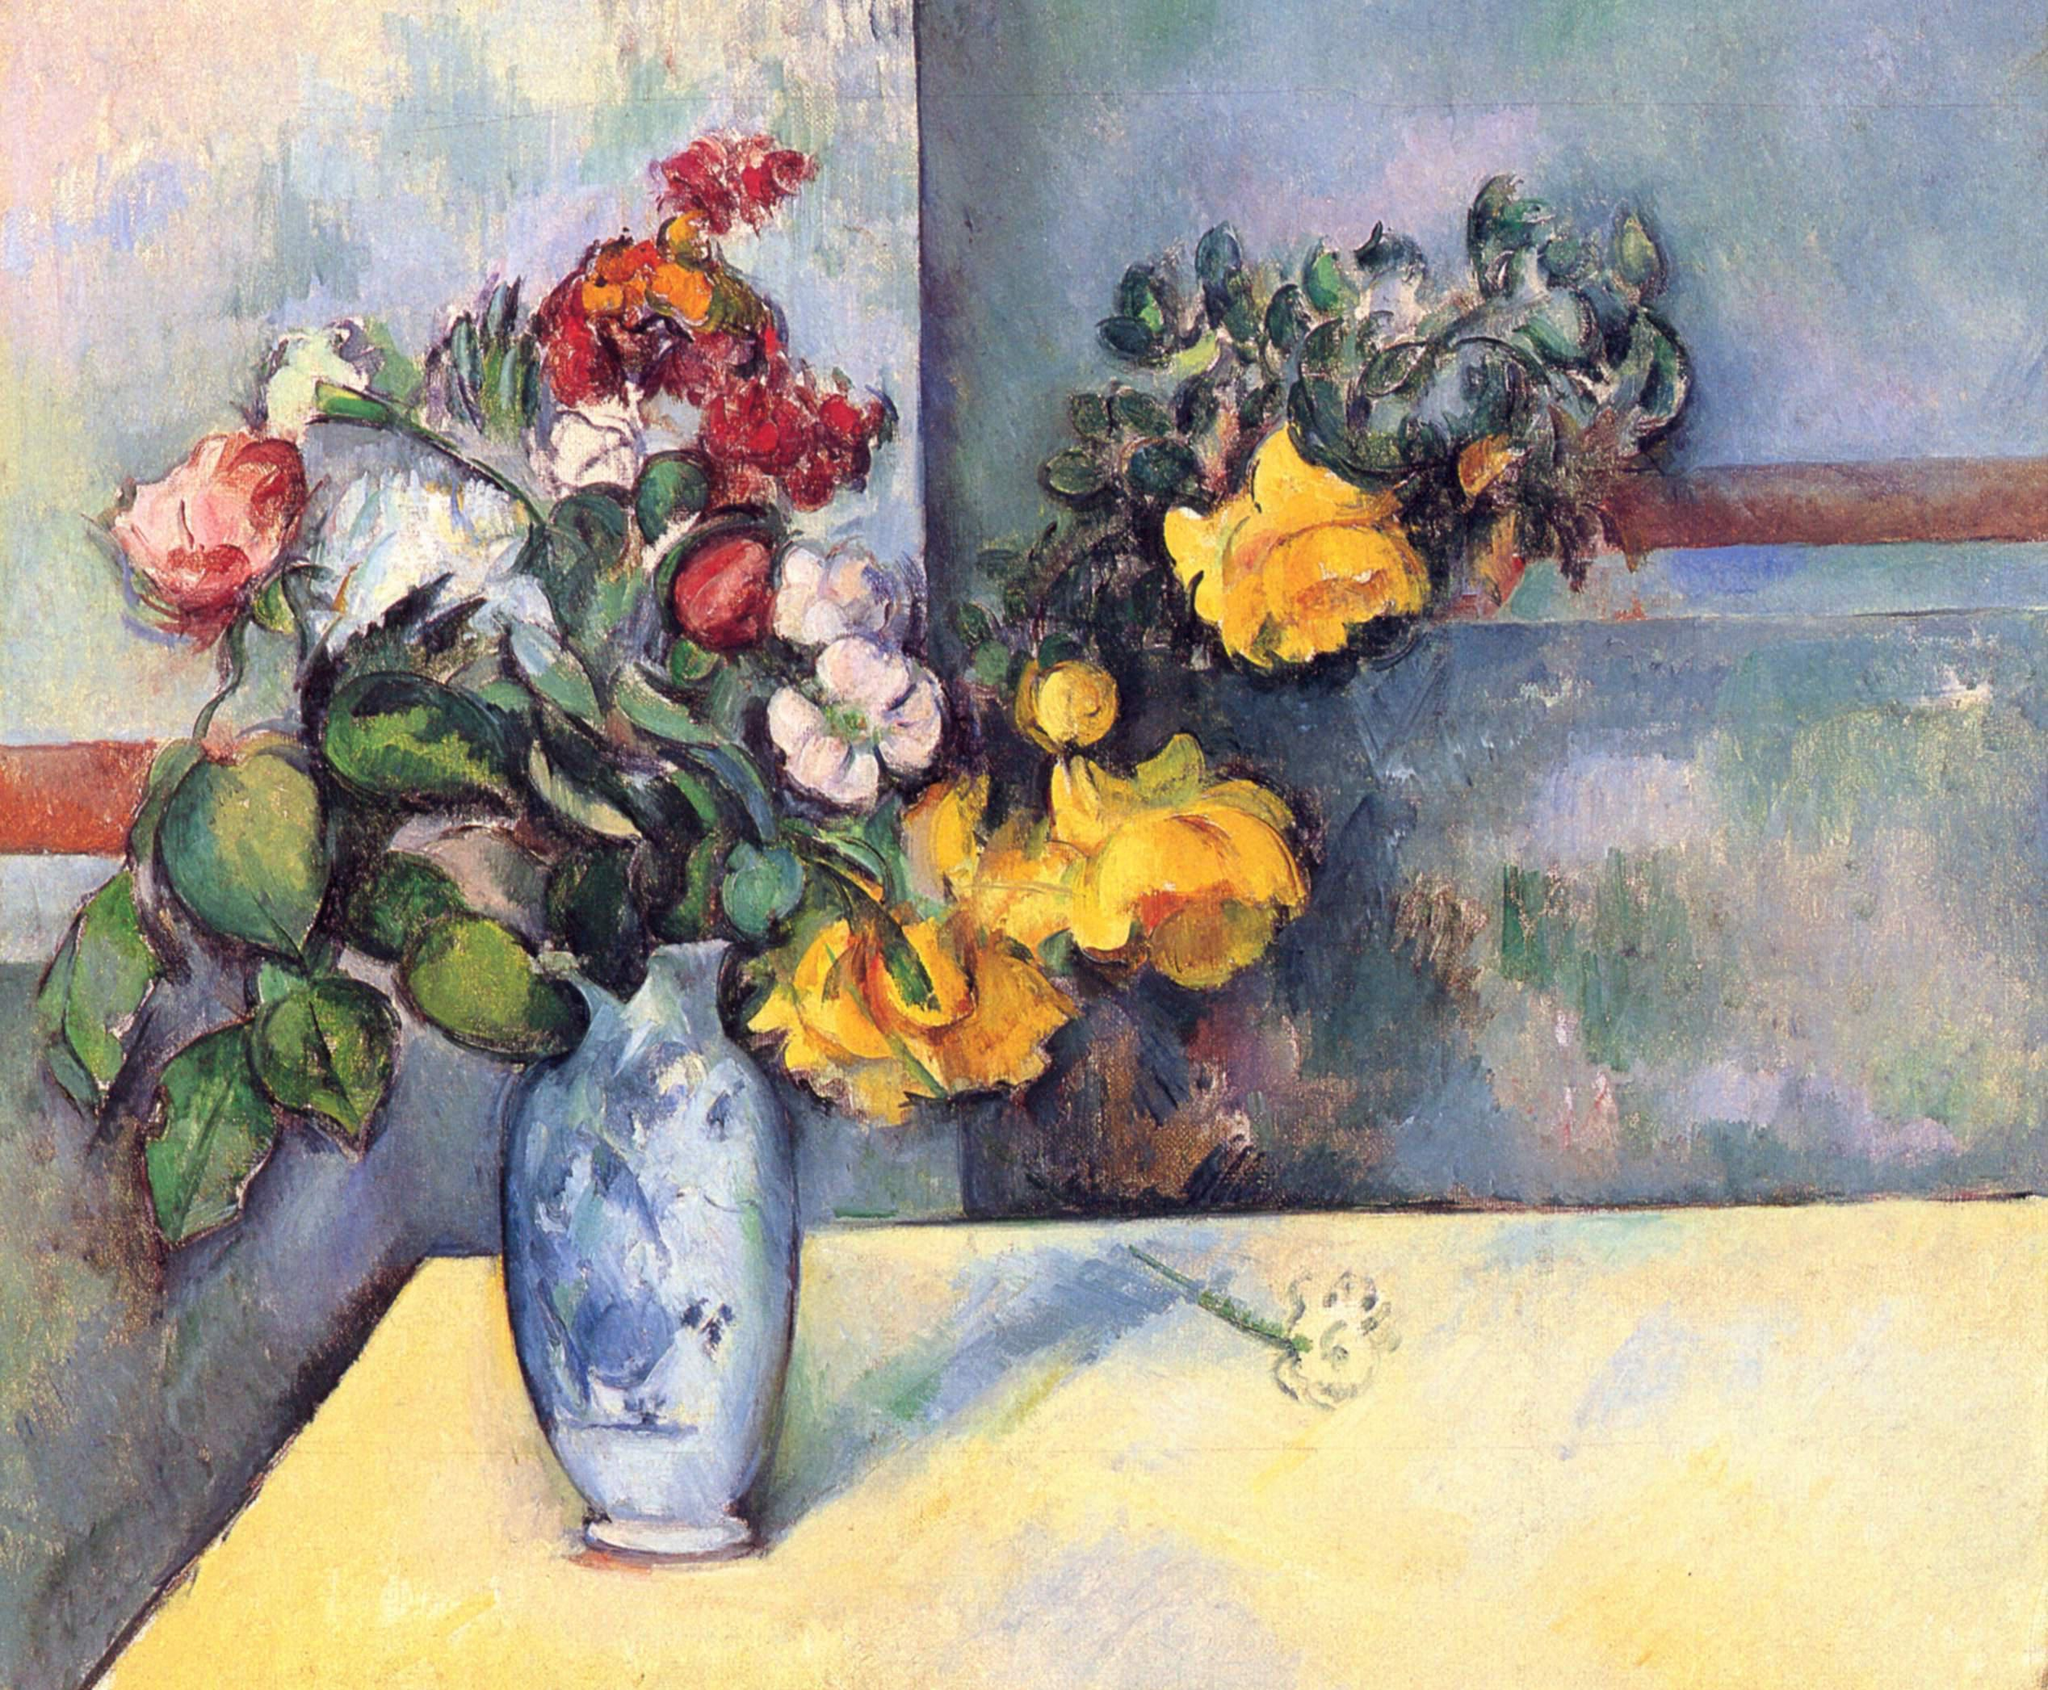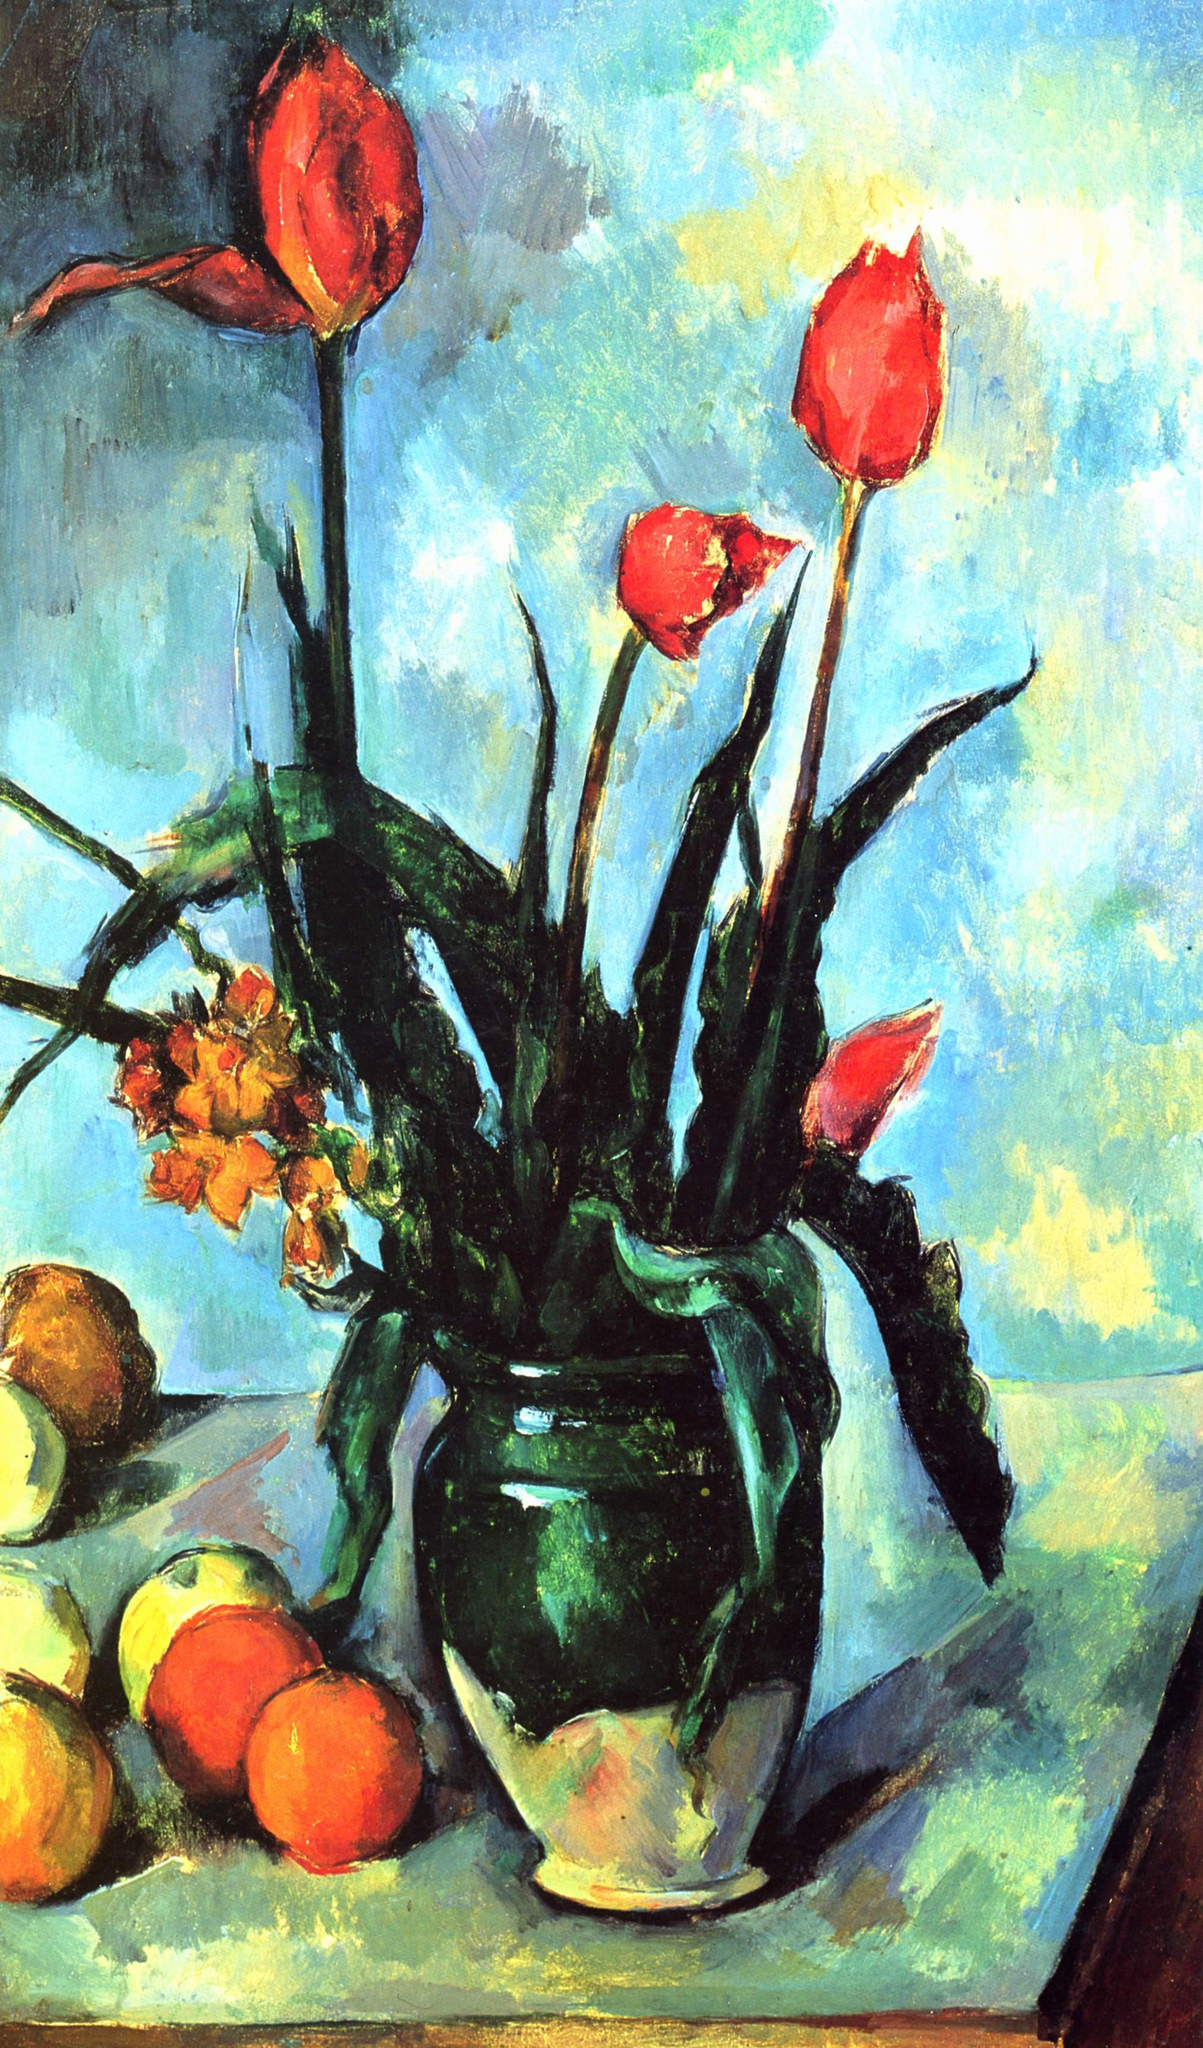The first image is the image on the left, the second image is the image on the right. Considering the images on both sides, is "One of the pictures shows a vase on a table with at least three round fruit also displayed on the table." valid? Answer yes or no. Yes. The first image is the image on the left, the second image is the image on the right. Assess this claim about the two images: "In one image there is a vase of flowers next to several pieces of fruit on a tabletop.". Correct or not? Answer yes or no. Yes. 